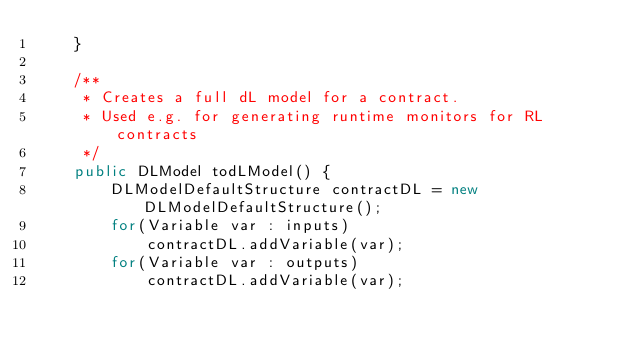<code> <loc_0><loc_0><loc_500><loc_500><_Java_>	}
	
	/**
	 * Creates a full dL model for a contract.
	 * Used e.g. for generating runtime monitors for RL contracts
	 */
	public DLModel todLModel() {
		DLModelDefaultStructure contractDL = new DLModelDefaultStructure();
		for(Variable var : inputs)
			contractDL.addVariable(var);
		for(Variable var : outputs)
			contractDL.addVariable(var);</code> 